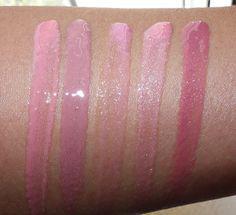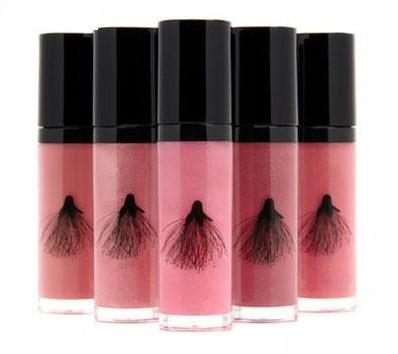The first image is the image on the left, the second image is the image on the right. For the images shown, is this caption "The five black caps of the makeup in the image on the right are fully visible." true? Answer yes or no. Yes. The first image is the image on the left, the second image is the image on the right. Considering the images on both sides, is "One image shows a lip makeup with its cover off." valid? Answer yes or no. No. 